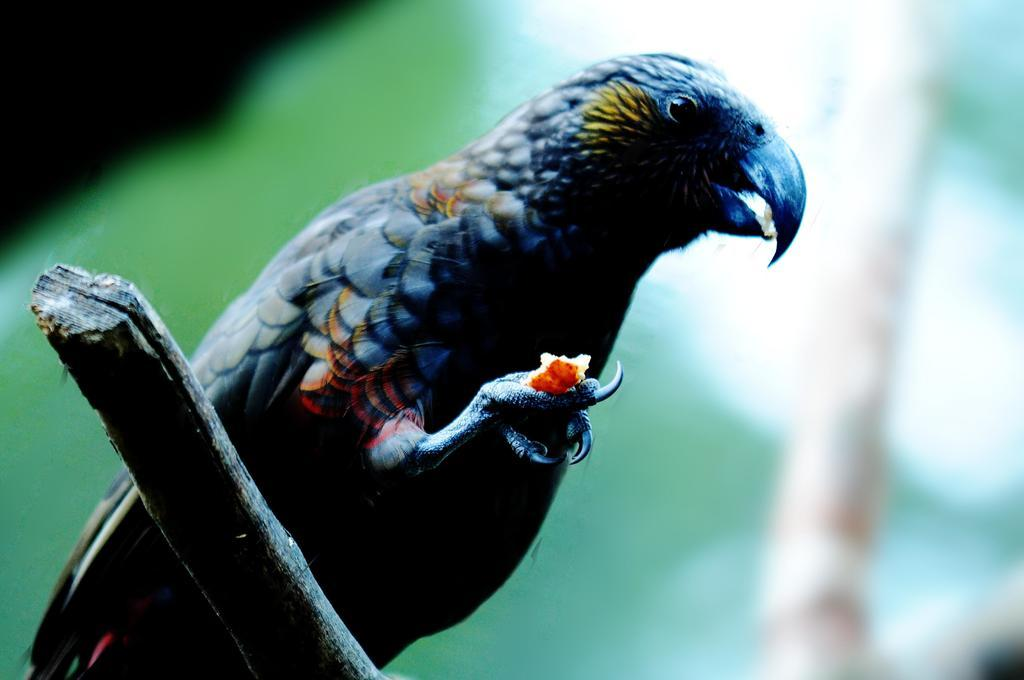What type of bird is in the image? There is a loriini bird in the image. Where is the bird located? The bird is in the wood. What is visible in the background of the image? There is an image visible in the background of the image. How many slopes can be seen in the image? There are no slopes present in the image. What type of wax is being used by the bird in the image? There is no wax present in the image, and the bird is not using any wax. 